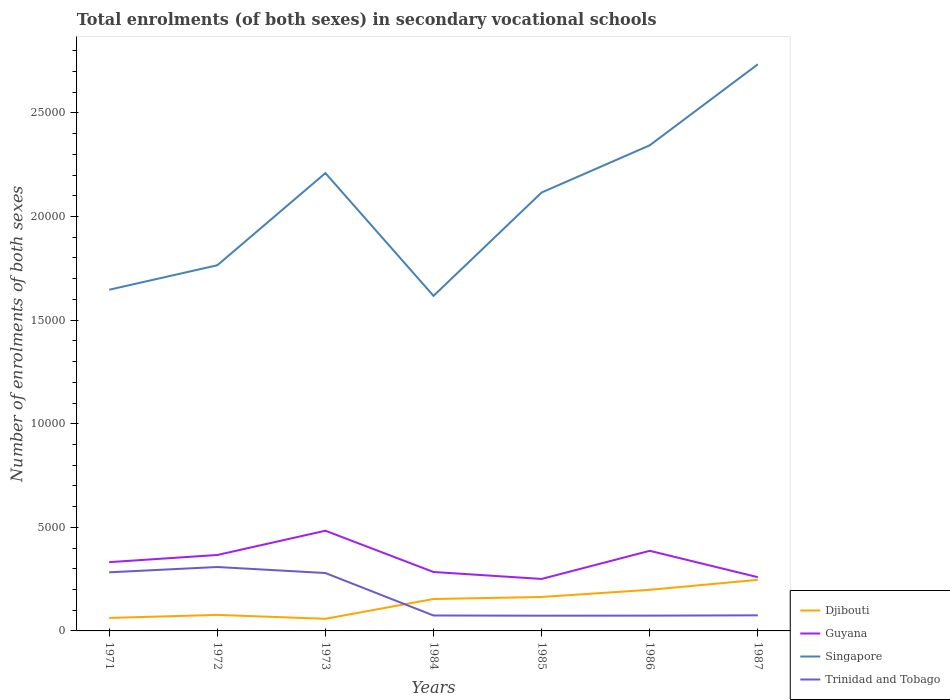Is the number of lines equal to the number of legend labels?
Offer a very short reply. Yes. Across all years, what is the maximum number of enrolments in secondary schools in Djibouti?
Provide a short and direct response. 585. In which year was the number of enrolments in secondary schools in Guyana maximum?
Your answer should be very brief. 1985. What is the total number of enrolments in secondary schools in Djibouti in the graph?
Provide a short and direct response. -444. What is the difference between the highest and the second highest number of enrolments in secondary schools in Singapore?
Ensure brevity in your answer.  1.12e+04. What is the difference between the highest and the lowest number of enrolments in secondary schools in Trinidad and Tobago?
Offer a terse response. 3. Is the number of enrolments in secondary schools in Singapore strictly greater than the number of enrolments in secondary schools in Trinidad and Tobago over the years?
Make the answer very short. No. How many lines are there?
Give a very brief answer. 4. What is the difference between two consecutive major ticks on the Y-axis?
Give a very brief answer. 5000. Does the graph contain any zero values?
Give a very brief answer. No. Does the graph contain grids?
Offer a very short reply. No. Where does the legend appear in the graph?
Ensure brevity in your answer.  Bottom right. What is the title of the graph?
Make the answer very short. Total enrolments (of both sexes) in secondary vocational schools. Does "Moldova" appear as one of the legend labels in the graph?
Provide a short and direct response. No. What is the label or title of the X-axis?
Provide a short and direct response. Years. What is the label or title of the Y-axis?
Provide a succinct answer. Number of enrolments of both sexes. What is the Number of enrolments of both sexes in Djibouti in 1971?
Provide a short and direct response. 627. What is the Number of enrolments of both sexes in Guyana in 1971?
Offer a terse response. 3319. What is the Number of enrolments of both sexes in Singapore in 1971?
Your response must be concise. 1.65e+04. What is the Number of enrolments of both sexes of Trinidad and Tobago in 1971?
Keep it short and to the point. 2829. What is the Number of enrolments of both sexes of Djibouti in 1972?
Your response must be concise. 774. What is the Number of enrolments of both sexes of Guyana in 1972?
Give a very brief answer. 3665. What is the Number of enrolments of both sexes of Singapore in 1972?
Provide a short and direct response. 1.76e+04. What is the Number of enrolments of both sexes of Trinidad and Tobago in 1972?
Your response must be concise. 3085. What is the Number of enrolments of both sexes in Djibouti in 1973?
Your answer should be very brief. 585. What is the Number of enrolments of both sexes of Guyana in 1973?
Give a very brief answer. 4836. What is the Number of enrolments of both sexes of Singapore in 1973?
Give a very brief answer. 2.21e+04. What is the Number of enrolments of both sexes in Trinidad and Tobago in 1973?
Provide a short and direct response. 2794. What is the Number of enrolments of both sexes in Djibouti in 1984?
Keep it short and to the point. 1540. What is the Number of enrolments of both sexes in Guyana in 1984?
Your response must be concise. 2844. What is the Number of enrolments of both sexes in Singapore in 1984?
Offer a terse response. 1.62e+04. What is the Number of enrolments of both sexes in Trinidad and Tobago in 1984?
Provide a short and direct response. 745. What is the Number of enrolments of both sexes in Djibouti in 1985?
Your response must be concise. 1639. What is the Number of enrolments of both sexes in Guyana in 1985?
Offer a very short reply. 2509. What is the Number of enrolments of both sexes in Singapore in 1985?
Your response must be concise. 2.12e+04. What is the Number of enrolments of both sexes in Trinidad and Tobago in 1985?
Keep it short and to the point. 735. What is the Number of enrolments of both sexes of Djibouti in 1986?
Give a very brief answer. 1984. What is the Number of enrolments of both sexes of Guyana in 1986?
Give a very brief answer. 3867. What is the Number of enrolments of both sexes of Singapore in 1986?
Offer a very short reply. 2.34e+04. What is the Number of enrolments of both sexes in Trinidad and Tobago in 1986?
Provide a short and direct response. 738. What is the Number of enrolments of both sexes in Djibouti in 1987?
Your answer should be compact. 2466. What is the Number of enrolments of both sexes of Guyana in 1987?
Your answer should be very brief. 2594. What is the Number of enrolments of both sexes of Singapore in 1987?
Offer a very short reply. 2.73e+04. What is the Number of enrolments of both sexes of Trinidad and Tobago in 1987?
Your answer should be compact. 753. Across all years, what is the maximum Number of enrolments of both sexes of Djibouti?
Provide a succinct answer. 2466. Across all years, what is the maximum Number of enrolments of both sexes of Guyana?
Offer a terse response. 4836. Across all years, what is the maximum Number of enrolments of both sexes in Singapore?
Your answer should be compact. 2.73e+04. Across all years, what is the maximum Number of enrolments of both sexes of Trinidad and Tobago?
Give a very brief answer. 3085. Across all years, what is the minimum Number of enrolments of both sexes in Djibouti?
Keep it short and to the point. 585. Across all years, what is the minimum Number of enrolments of both sexes of Guyana?
Make the answer very short. 2509. Across all years, what is the minimum Number of enrolments of both sexes in Singapore?
Your answer should be compact. 1.62e+04. Across all years, what is the minimum Number of enrolments of both sexes of Trinidad and Tobago?
Provide a succinct answer. 735. What is the total Number of enrolments of both sexes of Djibouti in the graph?
Your answer should be very brief. 9615. What is the total Number of enrolments of both sexes of Guyana in the graph?
Give a very brief answer. 2.36e+04. What is the total Number of enrolments of both sexes in Singapore in the graph?
Offer a terse response. 1.44e+05. What is the total Number of enrolments of both sexes of Trinidad and Tobago in the graph?
Your answer should be compact. 1.17e+04. What is the difference between the Number of enrolments of both sexes of Djibouti in 1971 and that in 1972?
Your answer should be very brief. -147. What is the difference between the Number of enrolments of both sexes in Guyana in 1971 and that in 1972?
Your answer should be very brief. -346. What is the difference between the Number of enrolments of both sexes of Singapore in 1971 and that in 1972?
Provide a short and direct response. -1181. What is the difference between the Number of enrolments of both sexes in Trinidad and Tobago in 1971 and that in 1972?
Make the answer very short. -256. What is the difference between the Number of enrolments of both sexes of Guyana in 1971 and that in 1973?
Offer a very short reply. -1517. What is the difference between the Number of enrolments of both sexes in Singapore in 1971 and that in 1973?
Keep it short and to the point. -5630. What is the difference between the Number of enrolments of both sexes of Djibouti in 1971 and that in 1984?
Provide a short and direct response. -913. What is the difference between the Number of enrolments of both sexes in Guyana in 1971 and that in 1984?
Provide a short and direct response. 475. What is the difference between the Number of enrolments of both sexes of Singapore in 1971 and that in 1984?
Keep it short and to the point. 296. What is the difference between the Number of enrolments of both sexes of Trinidad and Tobago in 1971 and that in 1984?
Offer a very short reply. 2084. What is the difference between the Number of enrolments of both sexes in Djibouti in 1971 and that in 1985?
Your answer should be very brief. -1012. What is the difference between the Number of enrolments of both sexes in Guyana in 1971 and that in 1985?
Make the answer very short. 810. What is the difference between the Number of enrolments of both sexes in Singapore in 1971 and that in 1985?
Your answer should be very brief. -4693. What is the difference between the Number of enrolments of both sexes of Trinidad and Tobago in 1971 and that in 1985?
Offer a very short reply. 2094. What is the difference between the Number of enrolments of both sexes of Djibouti in 1971 and that in 1986?
Ensure brevity in your answer.  -1357. What is the difference between the Number of enrolments of both sexes in Guyana in 1971 and that in 1986?
Your response must be concise. -548. What is the difference between the Number of enrolments of both sexes of Singapore in 1971 and that in 1986?
Offer a terse response. -6970. What is the difference between the Number of enrolments of both sexes in Trinidad and Tobago in 1971 and that in 1986?
Make the answer very short. 2091. What is the difference between the Number of enrolments of both sexes in Djibouti in 1971 and that in 1987?
Provide a succinct answer. -1839. What is the difference between the Number of enrolments of both sexes in Guyana in 1971 and that in 1987?
Your answer should be compact. 725. What is the difference between the Number of enrolments of both sexes of Singapore in 1971 and that in 1987?
Provide a succinct answer. -1.09e+04. What is the difference between the Number of enrolments of both sexes of Trinidad and Tobago in 1971 and that in 1987?
Make the answer very short. 2076. What is the difference between the Number of enrolments of both sexes in Djibouti in 1972 and that in 1973?
Give a very brief answer. 189. What is the difference between the Number of enrolments of both sexes of Guyana in 1972 and that in 1973?
Your response must be concise. -1171. What is the difference between the Number of enrolments of both sexes in Singapore in 1972 and that in 1973?
Keep it short and to the point. -4449. What is the difference between the Number of enrolments of both sexes in Trinidad and Tobago in 1972 and that in 1973?
Provide a succinct answer. 291. What is the difference between the Number of enrolments of both sexes in Djibouti in 1972 and that in 1984?
Provide a succinct answer. -766. What is the difference between the Number of enrolments of both sexes of Guyana in 1972 and that in 1984?
Give a very brief answer. 821. What is the difference between the Number of enrolments of both sexes in Singapore in 1972 and that in 1984?
Give a very brief answer. 1477. What is the difference between the Number of enrolments of both sexes in Trinidad and Tobago in 1972 and that in 1984?
Provide a succinct answer. 2340. What is the difference between the Number of enrolments of both sexes in Djibouti in 1972 and that in 1985?
Your response must be concise. -865. What is the difference between the Number of enrolments of both sexes of Guyana in 1972 and that in 1985?
Provide a short and direct response. 1156. What is the difference between the Number of enrolments of both sexes in Singapore in 1972 and that in 1985?
Your answer should be very brief. -3512. What is the difference between the Number of enrolments of both sexes of Trinidad and Tobago in 1972 and that in 1985?
Keep it short and to the point. 2350. What is the difference between the Number of enrolments of both sexes of Djibouti in 1972 and that in 1986?
Keep it short and to the point. -1210. What is the difference between the Number of enrolments of both sexes of Guyana in 1972 and that in 1986?
Ensure brevity in your answer.  -202. What is the difference between the Number of enrolments of both sexes in Singapore in 1972 and that in 1986?
Your answer should be compact. -5789. What is the difference between the Number of enrolments of both sexes of Trinidad and Tobago in 1972 and that in 1986?
Offer a terse response. 2347. What is the difference between the Number of enrolments of both sexes in Djibouti in 1972 and that in 1987?
Your response must be concise. -1692. What is the difference between the Number of enrolments of both sexes in Guyana in 1972 and that in 1987?
Your answer should be very brief. 1071. What is the difference between the Number of enrolments of both sexes in Singapore in 1972 and that in 1987?
Make the answer very short. -9700. What is the difference between the Number of enrolments of both sexes in Trinidad and Tobago in 1972 and that in 1987?
Provide a short and direct response. 2332. What is the difference between the Number of enrolments of both sexes in Djibouti in 1973 and that in 1984?
Offer a terse response. -955. What is the difference between the Number of enrolments of both sexes of Guyana in 1973 and that in 1984?
Make the answer very short. 1992. What is the difference between the Number of enrolments of both sexes of Singapore in 1973 and that in 1984?
Keep it short and to the point. 5926. What is the difference between the Number of enrolments of both sexes of Trinidad and Tobago in 1973 and that in 1984?
Offer a terse response. 2049. What is the difference between the Number of enrolments of both sexes of Djibouti in 1973 and that in 1985?
Make the answer very short. -1054. What is the difference between the Number of enrolments of both sexes of Guyana in 1973 and that in 1985?
Offer a very short reply. 2327. What is the difference between the Number of enrolments of both sexes of Singapore in 1973 and that in 1985?
Provide a succinct answer. 937. What is the difference between the Number of enrolments of both sexes of Trinidad and Tobago in 1973 and that in 1985?
Offer a terse response. 2059. What is the difference between the Number of enrolments of both sexes of Djibouti in 1973 and that in 1986?
Give a very brief answer. -1399. What is the difference between the Number of enrolments of both sexes in Guyana in 1973 and that in 1986?
Your answer should be very brief. 969. What is the difference between the Number of enrolments of both sexes of Singapore in 1973 and that in 1986?
Provide a short and direct response. -1340. What is the difference between the Number of enrolments of both sexes in Trinidad and Tobago in 1973 and that in 1986?
Your response must be concise. 2056. What is the difference between the Number of enrolments of both sexes in Djibouti in 1973 and that in 1987?
Ensure brevity in your answer.  -1881. What is the difference between the Number of enrolments of both sexes of Guyana in 1973 and that in 1987?
Your answer should be compact. 2242. What is the difference between the Number of enrolments of both sexes of Singapore in 1973 and that in 1987?
Give a very brief answer. -5251. What is the difference between the Number of enrolments of both sexes of Trinidad and Tobago in 1973 and that in 1987?
Offer a very short reply. 2041. What is the difference between the Number of enrolments of both sexes in Djibouti in 1984 and that in 1985?
Offer a very short reply. -99. What is the difference between the Number of enrolments of both sexes in Guyana in 1984 and that in 1985?
Offer a very short reply. 335. What is the difference between the Number of enrolments of both sexes of Singapore in 1984 and that in 1985?
Ensure brevity in your answer.  -4989. What is the difference between the Number of enrolments of both sexes of Djibouti in 1984 and that in 1986?
Provide a short and direct response. -444. What is the difference between the Number of enrolments of both sexes in Guyana in 1984 and that in 1986?
Your answer should be compact. -1023. What is the difference between the Number of enrolments of both sexes of Singapore in 1984 and that in 1986?
Give a very brief answer. -7266. What is the difference between the Number of enrolments of both sexes of Djibouti in 1984 and that in 1987?
Make the answer very short. -926. What is the difference between the Number of enrolments of both sexes of Guyana in 1984 and that in 1987?
Offer a very short reply. 250. What is the difference between the Number of enrolments of both sexes in Singapore in 1984 and that in 1987?
Your answer should be very brief. -1.12e+04. What is the difference between the Number of enrolments of both sexes in Djibouti in 1985 and that in 1986?
Keep it short and to the point. -345. What is the difference between the Number of enrolments of both sexes of Guyana in 1985 and that in 1986?
Ensure brevity in your answer.  -1358. What is the difference between the Number of enrolments of both sexes in Singapore in 1985 and that in 1986?
Keep it short and to the point. -2277. What is the difference between the Number of enrolments of both sexes in Trinidad and Tobago in 1985 and that in 1986?
Provide a short and direct response. -3. What is the difference between the Number of enrolments of both sexes in Djibouti in 1985 and that in 1987?
Make the answer very short. -827. What is the difference between the Number of enrolments of both sexes of Guyana in 1985 and that in 1987?
Offer a very short reply. -85. What is the difference between the Number of enrolments of both sexes in Singapore in 1985 and that in 1987?
Make the answer very short. -6188. What is the difference between the Number of enrolments of both sexes in Djibouti in 1986 and that in 1987?
Ensure brevity in your answer.  -482. What is the difference between the Number of enrolments of both sexes of Guyana in 1986 and that in 1987?
Offer a very short reply. 1273. What is the difference between the Number of enrolments of both sexes in Singapore in 1986 and that in 1987?
Offer a very short reply. -3911. What is the difference between the Number of enrolments of both sexes of Trinidad and Tobago in 1986 and that in 1987?
Give a very brief answer. -15. What is the difference between the Number of enrolments of both sexes in Djibouti in 1971 and the Number of enrolments of both sexes in Guyana in 1972?
Your answer should be compact. -3038. What is the difference between the Number of enrolments of both sexes in Djibouti in 1971 and the Number of enrolments of both sexes in Singapore in 1972?
Provide a succinct answer. -1.70e+04. What is the difference between the Number of enrolments of both sexes of Djibouti in 1971 and the Number of enrolments of both sexes of Trinidad and Tobago in 1972?
Your response must be concise. -2458. What is the difference between the Number of enrolments of both sexes of Guyana in 1971 and the Number of enrolments of both sexes of Singapore in 1972?
Your answer should be very brief. -1.43e+04. What is the difference between the Number of enrolments of both sexes of Guyana in 1971 and the Number of enrolments of both sexes of Trinidad and Tobago in 1972?
Provide a succinct answer. 234. What is the difference between the Number of enrolments of both sexes in Singapore in 1971 and the Number of enrolments of both sexes in Trinidad and Tobago in 1972?
Offer a terse response. 1.34e+04. What is the difference between the Number of enrolments of both sexes in Djibouti in 1971 and the Number of enrolments of both sexes in Guyana in 1973?
Provide a short and direct response. -4209. What is the difference between the Number of enrolments of both sexes of Djibouti in 1971 and the Number of enrolments of both sexes of Singapore in 1973?
Your response must be concise. -2.15e+04. What is the difference between the Number of enrolments of both sexes of Djibouti in 1971 and the Number of enrolments of both sexes of Trinidad and Tobago in 1973?
Provide a short and direct response. -2167. What is the difference between the Number of enrolments of both sexes in Guyana in 1971 and the Number of enrolments of both sexes in Singapore in 1973?
Provide a short and direct response. -1.88e+04. What is the difference between the Number of enrolments of both sexes of Guyana in 1971 and the Number of enrolments of both sexes of Trinidad and Tobago in 1973?
Your response must be concise. 525. What is the difference between the Number of enrolments of both sexes of Singapore in 1971 and the Number of enrolments of both sexes of Trinidad and Tobago in 1973?
Your response must be concise. 1.37e+04. What is the difference between the Number of enrolments of both sexes of Djibouti in 1971 and the Number of enrolments of both sexes of Guyana in 1984?
Provide a short and direct response. -2217. What is the difference between the Number of enrolments of both sexes in Djibouti in 1971 and the Number of enrolments of both sexes in Singapore in 1984?
Ensure brevity in your answer.  -1.55e+04. What is the difference between the Number of enrolments of both sexes of Djibouti in 1971 and the Number of enrolments of both sexes of Trinidad and Tobago in 1984?
Make the answer very short. -118. What is the difference between the Number of enrolments of both sexes in Guyana in 1971 and the Number of enrolments of both sexes in Singapore in 1984?
Offer a terse response. -1.29e+04. What is the difference between the Number of enrolments of both sexes in Guyana in 1971 and the Number of enrolments of both sexes in Trinidad and Tobago in 1984?
Give a very brief answer. 2574. What is the difference between the Number of enrolments of both sexes in Singapore in 1971 and the Number of enrolments of both sexes in Trinidad and Tobago in 1984?
Provide a succinct answer. 1.57e+04. What is the difference between the Number of enrolments of both sexes of Djibouti in 1971 and the Number of enrolments of both sexes of Guyana in 1985?
Your answer should be very brief. -1882. What is the difference between the Number of enrolments of both sexes in Djibouti in 1971 and the Number of enrolments of both sexes in Singapore in 1985?
Make the answer very short. -2.05e+04. What is the difference between the Number of enrolments of both sexes in Djibouti in 1971 and the Number of enrolments of both sexes in Trinidad and Tobago in 1985?
Your answer should be very brief. -108. What is the difference between the Number of enrolments of both sexes in Guyana in 1971 and the Number of enrolments of both sexes in Singapore in 1985?
Ensure brevity in your answer.  -1.78e+04. What is the difference between the Number of enrolments of both sexes of Guyana in 1971 and the Number of enrolments of both sexes of Trinidad and Tobago in 1985?
Keep it short and to the point. 2584. What is the difference between the Number of enrolments of both sexes in Singapore in 1971 and the Number of enrolments of both sexes in Trinidad and Tobago in 1985?
Make the answer very short. 1.57e+04. What is the difference between the Number of enrolments of both sexes in Djibouti in 1971 and the Number of enrolments of both sexes in Guyana in 1986?
Ensure brevity in your answer.  -3240. What is the difference between the Number of enrolments of both sexes of Djibouti in 1971 and the Number of enrolments of both sexes of Singapore in 1986?
Your answer should be compact. -2.28e+04. What is the difference between the Number of enrolments of both sexes in Djibouti in 1971 and the Number of enrolments of both sexes in Trinidad and Tobago in 1986?
Give a very brief answer. -111. What is the difference between the Number of enrolments of both sexes of Guyana in 1971 and the Number of enrolments of both sexes of Singapore in 1986?
Keep it short and to the point. -2.01e+04. What is the difference between the Number of enrolments of both sexes in Guyana in 1971 and the Number of enrolments of both sexes in Trinidad and Tobago in 1986?
Provide a succinct answer. 2581. What is the difference between the Number of enrolments of both sexes of Singapore in 1971 and the Number of enrolments of both sexes of Trinidad and Tobago in 1986?
Provide a succinct answer. 1.57e+04. What is the difference between the Number of enrolments of both sexes in Djibouti in 1971 and the Number of enrolments of both sexes in Guyana in 1987?
Provide a succinct answer. -1967. What is the difference between the Number of enrolments of both sexes of Djibouti in 1971 and the Number of enrolments of both sexes of Singapore in 1987?
Offer a terse response. -2.67e+04. What is the difference between the Number of enrolments of both sexes of Djibouti in 1971 and the Number of enrolments of both sexes of Trinidad and Tobago in 1987?
Keep it short and to the point. -126. What is the difference between the Number of enrolments of both sexes in Guyana in 1971 and the Number of enrolments of both sexes in Singapore in 1987?
Ensure brevity in your answer.  -2.40e+04. What is the difference between the Number of enrolments of both sexes in Guyana in 1971 and the Number of enrolments of both sexes in Trinidad and Tobago in 1987?
Give a very brief answer. 2566. What is the difference between the Number of enrolments of both sexes of Singapore in 1971 and the Number of enrolments of both sexes of Trinidad and Tobago in 1987?
Keep it short and to the point. 1.57e+04. What is the difference between the Number of enrolments of both sexes in Djibouti in 1972 and the Number of enrolments of both sexes in Guyana in 1973?
Offer a terse response. -4062. What is the difference between the Number of enrolments of both sexes of Djibouti in 1972 and the Number of enrolments of both sexes of Singapore in 1973?
Your response must be concise. -2.13e+04. What is the difference between the Number of enrolments of both sexes of Djibouti in 1972 and the Number of enrolments of both sexes of Trinidad and Tobago in 1973?
Your response must be concise. -2020. What is the difference between the Number of enrolments of both sexes of Guyana in 1972 and the Number of enrolments of both sexes of Singapore in 1973?
Your answer should be very brief. -1.84e+04. What is the difference between the Number of enrolments of both sexes of Guyana in 1972 and the Number of enrolments of both sexes of Trinidad and Tobago in 1973?
Give a very brief answer. 871. What is the difference between the Number of enrolments of both sexes in Singapore in 1972 and the Number of enrolments of both sexes in Trinidad and Tobago in 1973?
Provide a succinct answer. 1.49e+04. What is the difference between the Number of enrolments of both sexes of Djibouti in 1972 and the Number of enrolments of both sexes of Guyana in 1984?
Ensure brevity in your answer.  -2070. What is the difference between the Number of enrolments of both sexes in Djibouti in 1972 and the Number of enrolments of both sexes in Singapore in 1984?
Your response must be concise. -1.54e+04. What is the difference between the Number of enrolments of both sexes in Djibouti in 1972 and the Number of enrolments of both sexes in Trinidad and Tobago in 1984?
Keep it short and to the point. 29. What is the difference between the Number of enrolments of both sexes in Guyana in 1972 and the Number of enrolments of both sexes in Singapore in 1984?
Give a very brief answer. -1.25e+04. What is the difference between the Number of enrolments of both sexes in Guyana in 1972 and the Number of enrolments of both sexes in Trinidad and Tobago in 1984?
Provide a short and direct response. 2920. What is the difference between the Number of enrolments of both sexes of Singapore in 1972 and the Number of enrolments of both sexes of Trinidad and Tobago in 1984?
Give a very brief answer. 1.69e+04. What is the difference between the Number of enrolments of both sexes in Djibouti in 1972 and the Number of enrolments of both sexes in Guyana in 1985?
Keep it short and to the point. -1735. What is the difference between the Number of enrolments of both sexes of Djibouti in 1972 and the Number of enrolments of both sexes of Singapore in 1985?
Give a very brief answer. -2.04e+04. What is the difference between the Number of enrolments of both sexes of Djibouti in 1972 and the Number of enrolments of both sexes of Trinidad and Tobago in 1985?
Your response must be concise. 39. What is the difference between the Number of enrolments of both sexes of Guyana in 1972 and the Number of enrolments of both sexes of Singapore in 1985?
Ensure brevity in your answer.  -1.75e+04. What is the difference between the Number of enrolments of both sexes in Guyana in 1972 and the Number of enrolments of both sexes in Trinidad and Tobago in 1985?
Provide a short and direct response. 2930. What is the difference between the Number of enrolments of both sexes of Singapore in 1972 and the Number of enrolments of both sexes of Trinidad and Tobago in 1985?
Make the answer very short. 1.69e+04. What is the difference between the Number of enrolments of both sexes in Djibouti in 1972 and the Number of enrolments of both sexes in Guyana in 1986?
Your response must be concise. -3093. What is the difference between the Number of enrolments of both sexes of Djibouti in 1972 and the Number of enrolments of both sexes of Singapore in 1986?
Offer a terse response. -2.27e+04. What is the difference between the Number of enrolments of both sexes of Guyana in 1972 and the Number of enrolments of both sexes of Singapore in 1986?
Ensure brevity in your answer.  -1.98e+04. What is the difference between the Number of enrolments of both sexes in Guyana in 1972 and the Number of enrolments of both sexes in Trinidad and Tobago in 1986?
Provide a short and direct response. 2927. What is the difference between the Number of enrolments of both sexes of Singapore in 1972 and the Number of enrolments of both sexes of Trinidad and Tobago in 1986?
Provide a succinct answer. 1.69e+04. What is the difference between the Number of enrolments of both sexes in Djibouti in 1972 and the Number of enrolments of both sexes in Guyana in 1987?
Your answer should be compact. -1820. What is the difference between the Number of enrolments of both sexes of Djibouti in 1972 and the Number of enrolments of both sexes of Singapore in 1987?
Provide a short and direct response. -2.66e+04. What is the difference between the Number of enrolments of both sexes of Djibouti in 1972 and the Number of enrolments of both sexes of Trinidad and Tobago in 1987?
Your answer should be very brief. 21. What is the difference between the Number of enrolments of both sexes of Guyana in 1972 and the Number of enrolments of both sexes of Singapore in 1987?
Your response must be concise. -2.37e+04. What is the difference between the Number of enrolments of both sexes in Guyana in 1972 and the Number of enrolments of both sexes in Trinidad and Tobago in 1987?
Make the answer very short. 2912. What is the difference between the Number of enrolments of both sexes in Singapore in 1972 and the Number of enrolments of both sexes in Trinidad and Tobago in 1987?
Your answer should be compact. 1.69e+04. What is the difference between the Number of enrolments of both sexes in Djibouti in 1973 and the Number of enrolments of both sexes in Guyana in 1984?
Your response must be concise. -2259. What is the difference between the Number of enrolments of both sexes of Djibouti in 1973 and the Number of enrolments of both sexes of Singapore in 1984?
Provide a short and direct response. -1.56e+04. What is the difference between the Number of enrolments of both sexes of Djibouti in 1973 and the Number of enrolments of both sexes of Trinidad and Tobago in 1984?
Provide a succinct answer. -160. What is the difference between the Number of enrolments of both sexes in Guyana in 1973 and the Number of enrolments of both sexes in Singapore in 1984?
Your answer should be very brief. -1.13e+04. What is the difference between the Number of enrolments of both sexes in Guyana in 1973 and the Number of enrolments of both sexes in Trinidad and Tobago in 1984?
Your answer should be very brief. 4091. What is the difference between the Number of enrolments of both sexes of Singapore in 1973 and the Number of enrolments of both sexes of Trinidad and Tobago in 1984?
Your response must be concise. 2.14e+04. What is the difference between the Number of enrolments of both sexes in Djibouti in 1973 and the Number of enrolments of both sexes in Guyana in 1985?
Provide a succinct answer. -1924. What is the difference between the Number of enrolments of both sexes in Djibouti in 1973 and the Number of enrolments of both sexes in Singapore in 1985?
Your answer should be compact. -2.06e+04. What is the difference between the Number of enrolments of both sexes in Djibouti in 1973 and the Number of enrolments of both sexes in Trinidad and Tobago in 1985?
Provide a succinct answer. -150. What is the difference between the Number of enrolments of both sexes of Guyana in 1973 and the Number of enrolments of both sexes of Singapore in 1985?
Your answer should be very brief. -1.63e+04. What is the difference between the Number of enrolments of both sexes of Guyana in 1973 and the Number of enrolments of both sexes of Trinidad and Tobago in 1985?
Your answer should be very brief. 4101. What is the difference between the Number of enrolments of both sexes in Singapore in 1973 and the Number of enrolments of both sexes in Trinidad and Tobago in 1985?
Provide a succinct answer. 2.14e+04. What is the difference between the Number of enrolments of both sexes in Djibouti in 1973 and the Number of enrolments of both sexes in Guyana in 1986?
Your answer should be very brief. -3282. What is the difference between the Number of enrolments of both sexes of Djibouti in 1973 and the Number of enrolments of both sexes of Singapore in 1986?
Your answer should be very brief. -2.29e+04. What is the difference between the Number of enrolments of both sexes of Djibouti in 1973 and the Number of enrolments of both sexes of Trinidad and Tobago in 1986?
Offer a very short reply. -153. What is the difference between the Number of enrolments of both sexes of Guyana in 1973 and the Number of enrolments of both sexes of Singapore in 1986?
Give a very brief answer. -1.86e+04. What is the difference between the Number of enrolments of both sexes in Guyana in 1973 and the Number of enrolments of both sexes in Trinidad and Tobago in 1986?
Your answer should be compact. 4098. What is the difference between the Number of enrolments of both sexes of Singapore in 1973 and the Number of enrolments of both sexes of Trinidad and Tobago in 1986?
Offer a very short reply. 2.14e+04. What is the difference between the Number of enrolments of both sexes of Djibouti in 1973 and the Number of enrolments of both sexes of Guyana in 1987?
Your answer should be compact. -2009. What is the difference between the Number of enrolments of both sexes of Djibouti in 1973 and the Number of enrolments of both sexes of Singapore in 1987?
Make the answer very short. -2.68e+04. What is the difference between the Number of enrolments of both sexes in Djibouti in 1973 and the Number of enrolments of both sexes in Trinidad and Tobago in 1987?
Your response must be concise. -168. What is the difference between the Number of enrolments of both sexes in Guyana in 1973 and the Number of enrolments of both sexes in Singapore in 1987?
Make the answer very short. -2.25e+04. What is the difference between the Number of enrolments of both sexes of Guyana in 1973 and the Number of enrolments of both sexes of Trinidad and Tobago in 1987?
Your answer should be very brief. 4083. What is the difference between the Number of enrolments of both sexes of Singapore in 1973 and the Number of enrolments of both sexes of Trinidad and Tobago in 1987?
Keep it short and to the point. 2.13e+04. What is the difference between the Number of enrolments of both sexes of Djibouti in 1984 and the Number of enrolments of both sexes of Guyana in 1985?
Ensure brevity in your answer.  -969. What is the difference between the Number of enrolments of both sexes in Djibouti in 1984 and the Number of enrolments of both sexes in Singapore in 1985?
Your answer should be compact. -1.96e+04. What is the difference between the Number of enrolments of both sexes in Djibouti in 1984 and the Number of enrolments of both sexes in Trinidad and Tobago in 1985?
Give a very brief answer. 805. What is the difference between the Number of enrolments of both sexes in Guyana in 1984 and the Number of enrolments of both sexes in Singapore in 1985?
Provide a short and direct response. -1.83e+04. What is the difference between the Number of enrolments of both sexes of Guyana in 1984 and the Number of enrolments of both sexes of Trinidad and Tobago in 1985?
Offer a terse response. 2109. What is the difference between the Number of enrolments of both sexes in Singapore in 1984 and the Number of enrolments of both sexes in Trinidad and Tobago in 1985?
Offer a terse response. 1.54e+04. What is the difference between the Number of enrolments of both sexes of Djibouti in 1984 and the Number of enrolments of both sexes of Guyana in 1986?
Provide a succinct answer. -2327. What is the difference between the Number of enrolments of both sexes in Djibouti in 1984 and the Number of enrolments of both sexes in Singapore in 1986?
Provide a succinct answer. -2.19e+04. What is the difference between the Number of enrolments of both sexes in Djibouti in 1984 and the Number of enrolments of both sexes in Trinidad and Tobago in 1986?
Your response must be concise. 802. What is the difference between the Number of enrolments of both sexes in Guyana in 1984 and the Number of enrolments of both sexes in Singapore in 1986?
Your response must be concise. -2.06e+04. What is the difference between the Number of enrolments of both sexes of Guyana in 1984 and the Number of enrolments of both sexes of Trinidad and Tobago in 1986?
Offer a terse response. 2106. What is the difference between the Number of enrolments of both sexes of Singapore in 1984 and the Number of enrolments of both sexes of Trinidad and Tobago in 1986?
Make the answer very short. 1.54e+04. What is the difference between the Number of enrolments of both sexes of Djibouti in 1984 and the Number of enrolments of both sexes of Guyana in 1987?
Your answer should be very brief. -1054. What is the difference between the Number of enrolments of both sexes of Djibouti in 1984 and the Number of enrolments of both sexes of Singapore in 1987?
Your response must be concise. -2.58e+04. What is the difference between the Number of enrolments of both sexes of Djibouti in 1984 and the Number of enrolments of both sexes of Trinidad and Tobago in 1987?
Make the answer very short. 787. What is the difference between the Number of enrolments of both sexes in Guyana in 1984 and the Number of enrolments of both sexes in Singapore in 1987?
Give a very brief answer. -2.45e+04. What is the difference between the Number of enrolments of both sexes in Guyana in 1984 and the Number of enrolments of both sexes in Trinidad and Tobago in 1987?
Your response must be concise. 2091. What is the difference between the Number of enrolments of both sexes of Singapore in 1984 and the Number of enrolments of both sexes of Trinidad and Tobago in 1987?
Make the answer very short. 1.54e+04. What is the difference between the Number of enrolments of both sexes in Djibouti in 1985 and the Number of enrolments of both sexes in Guyana in 1986?
Make the answer very short. -2228. What is the difference between the Number of enrolments of both sexes of Djibouti in 1985 and the Number of enrolments of both sexes of Singapore in 1986?
Your answer should be compact. -2.18e+04. What is the difference between the Number of enrolments of both sexes of Djibouti in 1985 and the Number of enrolments of both sexes of Trinidad and Tobago in 1986?
Give a very brief answer. 901. What is the difference between the Number of enrolments of both sexes in Guyana in 1985 and the Number of enrolments of both sexes in Singapore in 1986?
Ensure brevity in your answer.  -2.09e+04. What is the difference between the Number of enrolments of both sexes of Guyana in 1985 and the Number of enrolments of both sexes of Trinidad and Tobago in 1986?
Your answer should be compact. 1771. What is the difference between the Number of enrolments of both sexes in Singapore in 1985 and the Number of enrolments of both sexes in Trinidad and Tobago in 1986?
Offer a terse response. 2.04e+04. What is the difference between the Number of enrolments of both sexes of Djibouti in 1985 and the Number of enrolments of both sexes of Guyana in 1987?
Make the answer very short. -955. What is the difference between the Number of enrolments of both sexes of Djibouti in 1985 and the Number of enrolments of both sexes of Singapore in 1987?
Your answer should be very brief. -2.57e+04. What is the difference between the Number of enrolments of both sexes of Djibouti in 1985 and the Number of enrolments of both sexes of Trinidad and Tobago in 1987?
Provide a succinct answer. 886. What is the difference between the Number of enrolments of both sexes of Guyana in 1985 and the Number of enrolments of both sexes of Singapore in 1987?
Your response must be concise. -2.48e+04. What is the difference between the Number of enrolments of both sexes in Guyana in 1985 and the Number of enrolments of both sexes in Trinidad and Tobago in 1987?
Make the answer very short. 1756. What is the difference between the Number of enrolments of both sexes in Singapore in 1985 and the Number of enrolments of both sexes in Trinidad and Tobago in 1987?
Give a very brief answer. 2.04e+04. What is the difference between the Number of enrolments of both sexes in Djibouti in 1986 and the Number of enrolments of both sexes in Guyana in 1987?
Keep it short and to the point. -610. What is the difference between the Number of enrolments of both sexes in Djibouti in 1986 and the Number of enrolments of both sexes in Singapore in 1987?
Ensure brevity in your answer.  -2.54e+04. What is the difference between the Number of enrolments of both sexes of Djibouti in 1986 and the Number of enrolments of both sexes of Trinidad and Tobago in 1987?
Your answer should be very brief. 1231. What is the difference between the Number of enrolments of both sexes of Guyana in 1986 and the Number of enrolments of both sexes of Singapore in 1987?
Keep it short and to the point. -2.35e+04. What is the difference between the Number of enrolments of both sexes of Guyana in 1986 and the Number of enrolments of both sexes of Trinidad and Tobago in 1987?
Provide a short and direct response. 3114. What is the difference between the Number of enrolments of both sexes of Singapore in 1986 and the Number of enrolments of both sexes of Trinidad and Tobago in 1987?
Your response must be concise. 2.27e+04. What is the average Number of enrolments of both sexes in Djibouti per year?
Ensure brevity in your answer.  1373.57. What is the average Number of enrolments of both sexes of Guyana per year?
Provide a succinct answer. 3376.29. What is the average Number of enrolments of both sexes of Singapore per year?
Offer a terse response. 2.06e+04. What is the average Number of enrolments of both sexes of Trinidad and Tobago per year?
Keep it short and to the point. 1668.43. In the year 1971, what is the difference between the Number of enrolments of both sexes in Djibouti and Number of enrolments of both sexes in Guyana?
Make the answer very short. -2692. In the year 1971, what is the difference between the Number of enrolments of both sexes in Djibouti and Number of enrolments of both sexes in Singapore?
Make the answer very short. -1.58e+04. In the year 1971, what is the difference between the Number of enrolments of both sexes in Djibouti and Number of enrolments of both sexes in Trinidad and Tobago?
Offer a very short reply. -2202. In the year 1971, what is the difference between the Number of enrolments of both sexes in Guyana and Number of enrolments of both sexes in Singapore?
Provide a succinct answer. -1.31e+04. In the year 1971, what is the difference between the Number of enrolments of both sexes of Guyana and Number of enrolments of both sexes of Trinidad and Tobago?
Give a very brief answer. 490. In the year 1971, what is the difference between the Number of enrolments of both sexes of Singapore and Number of enrolments of both sexes of Trinidad and Tobago?
Make the answer very short. 1.36e+04. In the year 1972, what is the difference between the Number of enrolments of both sexes of Djibouti and Number of enrolments of both sexes of Guyana?
Offer a terse response. -2891. In the year 1972, what is the difference between the Number of enrolments of both sexes in Djibouti and Number of enrolments of both sexes in Singapore?
Provide a succinct answer. -1.69e+04. In the year 1972, what is the difference between the Number of enrolments of both sexes of Djibouti and Number of enrolments of both sexes of Trinidad and Tobago?
Your response must be concise. -2311. In the year 1972, what is the difference between the Number of enrolments of both sexes of Guyana and Number of enrolments of both sexes of Singapore?
Your answer should be very brief. -1.40e+04. In the year 1972, what is the difference between the Number of enrolments of both sexes of Guyana and Number of enrolments of both sexes of Trinidad and Tobago?
Give a very brief answer. 580. In the year 1972, what is the difference between the Number of enrolments of both sexes of Singapore and Number of enrolments of both sexes of Trinidad and Tobago?
Your answer should be very brief. 1.46e+04. In the year 1973, what is the difference between the Number of enrolments of both sexes in Djibouti and Number of enrolments of both sexes in Guyana?
Provide a succinct answer. -4251. In the year 1973, what is the difference between the Number of enrolments of both sexes in Djibouti and Number of enrolments of both sexes in Singapore?
Give a very brief answer. -2.15e+04. In the year 1973, what is the difference between the Number of enrolments of both sexes of Djibouti and Number of enrolments of both sexes of Trinidad and Tobago?
Your answer should be compact. -2209. In the year 1973, what is the difference between the Number of enrolments of both sexes of Guyana and Number of enrolments of both sexes of Singapore?
Your response must be concise. -1.73e+04. In the year 1973, what is the difference between the Number of enrolments of both sexes in Guyana and Number of enrolments of both sexes in Trinidad and Tobago?
Give a very brief answer. 2042. In the year 1973, what is the difference between the Number of enrolments of both sexes of Singapore and Number of enrolments of both sexes of Trinidad and Tobago?
Keep it short and to the point. 1.93e+04. In the year 1984, what is the difference between the Number of enrolments of both sexes in Djibouti and Number of enrolments of both sexes in Guyana?
Provide a succinct answer. -1304. In the year 1984, what is the difference between the Number of enrolments of both sexes in Djibouti and Number of enrolments of both sexes in Singapore?
Your response must be concise. -1.46e+04. In the year 1984, what is the difference between the Number of enrolments of both sexes of Djibouti and Number of enrolments of both sexes of Trinidad and Tobago?
Give a very brief answer. 795. In the year 1984, what is the difference between the Number of enrolments of both sexes in Guyana and Number of enrolments of both sexes in Singapore?
Offer a very short reply. -1.33e+04. In the year 1984, what is the difference between the Number of enrolments of both sexes in Guyana and Number of enrolments of both sexes in Trinidad and Tobago?
Offer a very short reply. 2099. In the year 1984, what is the difference between the Number of enrolments of both sexes of Singapore and Number of enrolments of both sexes of Trinidad and Tobago?
Your answer should be compact. 1.54e+04. In the year 1985, what is the difference between the Number of enrolments of both sexes of Djibouti and Number of enrolments of both sexes of Guyana?
Keep it short and to the point. -870. In the year 1985, what is the difference between the Number of enrolments of both sexes of Djibouti and Number of enrolments of both sexes of Singapore?
Make the answer very short. -1.95e+04. In the year 1985, what is the difference between the Number of enrolments of both sexes of Djibouti and Number of enrolments of both sexes of Trinidad and Tobago?
Provide a short and direct response. 904. In the year 1985, what is the difference between the Number of enrolments of both sexes of Guyana and Number of enrolments of both sexes of Singapore?
Ensure brevity in your answer.  -1.87e+04. In the year 1985, what is the difference between the Number of enrolments of both sexes in Guyana and Number of enrolments of both sexes in Trinidad and Tobago?
Your answer should be compact. 1774. In the year 1985, what is the difference between the Number of enrolments of both sexes in Singapore and Number of enrolments of both sexes in Trinidad and Tobago?
Provide a succinct answer. 2.04e+04. In the year 1986, what is the difference between the Number of enrolments of both sexes in Djibouti and Number of enrolments of both sexes in Guyana?
Your response must be concise. -1883. In the year 1986, what is the difference between the Number of enrolments of both sexes in Djibouti and Number of enrolments of both sexes in Singapore?
Keep it short and to the point. -2.15e+04. In the year 1986, what is the difference between the Number of enrolments of both sexes in Djibouti and Number of enrolments of both sexes in Trinidad and Tobago?
Make the answer very short. 1246. In the year 1986, what is the difference between the Number of enrolments of both sexes in Guyana and Number of enrolments of both sexes in Singapore?
Make the answer very short. -1.96e+04. In the year 1986, what is the difference between the Number of enrolments of both sexes of Guyana and Number of enrolments of both sexes of Trinidad and Tobago?
Offer a very short reply. 3129. In the year 1986, what is the difference between the Number of enrolments of both sexes in Singapore and Number of enrolments of both sexes in Trinidad and Tobago?
Give a very brief answer. 2.27e+04. In the year 1987, what is the difference between the Number of enrolments of both sexes in Djibouti and Number of enrolments of both sexes in Guyana?
Give a very brief answer. -128. In the year 1987, what is the difference between the Number of enrolments of both sexes of Djibouti and Number of enrolments of both sexes of Singapore?
Provide a short and direct response. -2.49e+04. In the year 1987, what is the difference between the Number of enrolments of both sexes in Djibouti and Number of enrolments of both sexes in Trinidad and Tobago?
Provide a short and direct response. 1713. In the year 1987, what is the difference between the Number of enrolments of both sexes of Guyana and Number of enrolments of both sexes of Singapore?
Keep it short and to the point. -2.48e+04. In the year 1987, what is the difference between the Number of enrolments of both sexes of Guyana and Number of enrolments of both sexes of Trinidad and Tobago?
Provide a short and direct response. 1841. In the year 1987, what is the difference between the Number of enrolments of both sexes of Singapore and Number of enrolments of both sexes of Trinidad and Tobago?
Your response must be concise. 2.66e+04. What is the ratio of the Number of enrolments of both sexes of Djibouti in 1971 to that in 1972?
Offer a terse response. 0.81. What is the ratio of the Number of enrolments of both sexes of Guyana in 1971 to that in 1972?
Offer a very short reply. 0.91. What is the ratio of the Number of enrolments of both sexes of Singapore in 1971 to that in 1972?
Ensure brevity in your answer.  0.93. What is the ratio of the Number of enrolments of both sexes in Trinidad and Tobago in 1971 to that in 1972?
Your answer should be very brief. 0.92. What is the ratio of the Number of enrolments of both sexes in Djibouti in 1971 to that in 1973?
Offer a very short reply. 1.07. What is the ratio of the Number of enrolments of both sexes of Guyana in 1971 to that in 1973?
Provide a succinct answer. 0.69. What is the ratio of the Number of enrolments of both sexes in Singapore in 1971 to that in 1973?
Ensure brevity in your answer.  0.75. What is the ratio of the Number of enrolments of both sexes of Trinidad and Tobago in 1971 to that in 1973?
Provide a short and direct response. 1.01. What is the ratio of the Number of enrolments of both sexes in Djibouti in 1971 to that in 1984?
Offer a very short reply. 0.41. What is the ratio of the Number of enrolments of both sexes in Guyana in 1971 to that in 1984?
Your answer should be compact. 1.17. What is the ratio of the Number of enrolments of both sexes in Singapore in 1971 to that in 1984?
Provide a short and direct response. 1.02. What is the ratio of the Number of enrolments of both sexes of Trinidad and Tobago in 1971 to that in 1984?
Your response must be concise. 3.8. What is the ratio of the Number of enrolments of both sexes in Djibouti in 1971 to that in 1985?
Provide a short and direct response. 0.38. What is the ratio of the Number of enrolments of both sexes of Guyana in 1971 to that in 1985?
Make the answer very short. 1.32. What is the ratio of the Number of enrolments of both sexes of Singapore in 1971 to that in 1985?
Provide a short and direct response. 0.78. What is the ratio of the Number of enrolments of both sexes in Trinidad and Tobago in 1971 to that in 1985?
Your answer should be very brief. 3.85. What is the ratio of the Number of enrolments of both sexes of Djibouti in 1971 to that in 1986?
Your answer should be compact. 0.32. What is the ratio of the Number of enrolments of both sexes of Guyana in 1971 to that in 1986?
Give a very brief answer. 0.86. What is the ratio of the Number of enrolments of both sexes in Singapore in 1971 to that in 1986?
Your response must be concise. 0.7. What is the ratio of the Number of enrolments of both sexes in Trinidad and Tobago in 1971 to that in 1986?
Keep it short and to the point. 3.83. What is the ratio of the Number of enrolments of both sexes in Djibouti in 1971 to that in 1987?
Offer a terse response. 0.25. What is the ratio of the Number of enrolments of both sexes of Guyana in 1971 to that in 1987?
Your response must be concise. 1.28. What is the ratio of the Number of enrolments of both sexes of Singapore in 1971 to that in 1987?
Keep it short and to the point. 0.6. What is the ratio of the Number of enrolments of both sexes in Trinidad and Tobago in 1971 to that in 1987?
Provide a short and direct response. 3.76. What is the ratio of the Number of enrolments of both sexes of Djibouti in 1972 to that in 1973?
Give a very brief answer. 1.32. What is the ratio of the Number of enrolments of both sexes in Guyana in 1972 to that in 1973?
Offer a very short reply. 0.76. What is the ratio of the Number of enrolments of both sexes in Singapore in 1972 to that in 1973?
Keep it short and to the point. 0.8. What is the ratio of the Number of enrolments of both sexes of Trinidad and Tobago in 1972 to that in 1973?
Provide a short and direct response. 1.1. What is the ratio of the Number of enrolments of both sexes of Djibouti in 1972 to that in 1984?
Give a very brief answer. 0.5. What is the ratio of the Number of enrolments of both sexes in Guyana in 1972 to that in 1984?
Provide a succinct answer. 1.29. What is the ratio of the Number of enrolments of both sexes in Singapore in 1972 to that in 1984?
Offer a very short reply. 1.09. What is the ratio of the Number of enrolments of both sexes in Trinidad and Tobago in 1972 to that in 1984?
Your answer should be very brief. 4.14. What is the ratio of the Number of enrolments of both sexes in Djibouti in 1972 to that in 1985?
Ensure brevity in your answer.  0.47. What is the ratio of the Number of enrolments of both sexes of Guyana in 1972 to that in 1985?
Your answer should be very brief. 1.46. What is the ratio of the Number of enrolments of both sexes of Singapore in 1972 to that in 1985?
Offer a terse response. 0.83. What is the ratio of the Number of enrolments of both sexes of Trinidad and Tobago in 1972 to that in 1985?
Your answer should be very brief. 4.2. What is the ratio of the Number of enrolments of both sexes of Djibouti in 1972 to that in 1986?
Give a very brief answer. 0.39. What is the ratio of the Number of enrolments of both sexes of Guyana in 1972 to that in 1986?
Offer a very short reply. 0.95. What is the ratio of the Number of enrolments of both sexes in Singapore in 1972 to that in 1986?
Make the answer very short. 0.75. What is the ratio of the Number of enrolments of both sexes in Trinidad and Tobago in 1972 to that in 1986?
Provide a succinct answer. 4.18. What is the ratio of the Number of enrolments of both sexes of Djibouti in 1972 to that in 1987?
Provide a short and direct response. 0.31. What is the ratio of the Number of enrolments of both sexes of Guyana in 1972 to that in 1987?
Offer a very short reply. 1.41. What is the ratio of the Number of enrolments of both sexes in Singapore in 1972 to that in 1987?
Offer a very short reply. 0.65. What is the ratio of the Number of enrolments of both sexes in Trinidad and Tobago in 1972 to that in 1987?
Your response must be concise. 4.1. What is the ratio of the Number of enrolments of both sexes of Djibouti in 1973 to that in 1984?
Offer a terse response. 0.38. What is the ratio of the Number of enrolments of both sexes of Guyana in 1973 to that in 1984?
Offer a terse response. 1.7. What is the ratio of the Number of enrolments of both sexes of Singapore in 1973 to that in 1984?
Your answer should be compact. 1.37. What is the ratio of the Number of enrolments of both sexes in Trinidad and Tobago in 1973 to that in 1984?
Provide a short and direct response. 3.75. What is the ratio of the Number of enrolments of both sexes of Djibouti in 1973 to that in 1985?
Your response must be concise. 0.36. What is the ratio of the Number of enrolments of both sexes of Guyana in 1973 to that in 1985?
Give a very brief answer. 1.93. What is the ratio of the Number of enrolments of both sexes of Singapore in 1973 to that in 1985?
Give a very brief answer. 1.04. What is the ratio of the Number of enrolments of both sexes of Trinidad and Tobago in 1973 to that in 1985?
Ensure brevity in your answer.  3.8. What is the ratio of the Number of enrolments of both sexes of Djibouti in 1973 to that in 1986?
Your answer should be very brief. 0.29. What is the ratio of the Number of enrolments of both sexes of Guyana in 1973 to that in 1986?
Ensure brevity in your answer.  1.25. What is the ratio of the Number of enrolments of both sexes in Singapore in 1973 to that in 1986?
Ensure brevity in your answer.  0.94. What is the ratio of the Number of enrolments of both sexes in Trinidad and Tobago in 1973 to that in 1986?
Ensure brevity in your answer.  3.79. What is the ratio of the Number of enrolments of both sexes of Djibouti in 1973 to that in 1987?
Provide a succinct answer. 0.24. What is the ratio of the Number of enrolments of both sexes of Guyana in 1973 to that in 1987?
Provide a succinct answer. 1.86. What is the ratio of the Number of enrolments of both sexes of Singapore in 1973 to that in 1987?
Ensure brevity in your answer.  0.81. What is the ratio of the Number of enrolments of both sexes of Trinidad and Tobago in 1973 to that in 1987?
Give a very brief answer. 3.71. What is the ratio of the Number of enrolments of both sexes of Djibouti in 1984 to that in 1985?
Provide a succinct answer. 0.94. What is the ratio of the Number of enrolments of both sexes in Guyana in 1984 to that in 1985?
Your answer should be very brief. 1.13. What is the ratio of the Number of enrolments of both sexes of Singapore in 1984 to that in 1985?
Provide a short and direct response. 0.76. What is the ratio of the Number of enrolments of both sexes of Trinidad and Tobago in 1984 to that in 1985?
Offer a very short reply. 1.01. What is the ratio of the Number of enrolments of both sexes of Djibouti in 1984 to that in 1986?
Make the answer very short. 0.78. What is the ratio of the Number of enrolments of both sexes of Guyana in 1984 to that in 1986?
Your answer should be compact. 0.74. What is the ratio of the Number of enrolments of both sexes of Singapore in 1984 to that in 1986?
Your response must be concise. 0.69. What is the ratio of the Number of enrolments of both sexes in Trinidad and Tobago in 1984 to that in 1986?
Provide a succinct answer. 1.01. What is the ratio of the Number of enrolments of both sexes in Djibouti in 1984 to that in 1987?
Offer a very short reply. 0.62. What is the ratio of the Number of enrolments of both sexes of Guyana in 1984 to that in 1987?
Your response must be concise. 1.1. What is the ratio of the Number of enrolments of both sexes in Singapore in 1984 to that in 1987?
Keep it short and to the point. 0.59. What is the ratio of the Number of enrolments of both sexes of Trinidad and Tobago in 1984 to that in 1987?
Provide a short and direct response. 0.99. What is the ratio of the Number of enrolments of both sexes in Djibouti in 1985 to that in 1986?
Give a very brief answer. 0.83. What is the ratio of the Number of enrolments of both sexes in Guyana in 1985 to that in 1986?
Offer a very short reply. 0.65. What is the ratio of the Number of enrolments of both sexes of Singapore in 1985 to that in 1986?
Offer a very short reply. 0.9. What is the ratio of the Number of enrolments of both sexes of Trinidad and Tobago in 1985 to that in 1986?
Ensure brevity in your answer.  1. What is the ratio of the Number of enrolments of both sexes of Djibouti in 1985 to that in 1987?
Provide a short and direct response. 0.66. What is the ratio of the Number of enrolments of both sexes in Guyana in 1985 to that in 1987?
Offer a terse response. 0.97. What is the ratio of the Number of enrolments of both sexes in Singapore in 1985 to that in 1987?
Offer a very short reply. 0.77. What is the ratio of the Number of enrolments of both sexes of Trinidad and Tobago in 1985 to that in 1987?
Keep it short and to the point. 0.98. What is the ratio of the Number of enrolments of both sexes in Djibouti in 1986 to that in 1987?
Provide a short and direct response. 0.8. What is the ratio of the Number of enrolments of both sexes of Guyana in 1986 to that in 1987?
Make the answer very short. 1.49. What is the ratio of the Number of enrolments of both sexes in Singapore in 1986 to that in 1987?
Give a very brief answer. 0.86. What is the ratio of the Number of enrolments of both sexes in Trinidad and Tobago in 1986 to that in 1987?
Provide a short and direct response. 0.98. What is the difference between the highest and the second highest Number of enrolments of both sexes of Djibouti?
Keep it short and to the point. 482. What is the difference between the highest and the second highest Number of enrolments of both sexes of Guyana?
Give a very brief answer. 969. What is the difference between the highest and the second highest Number of enrolments of both sexes of Singapore?
Your answer should be compact. 3911. What is the difference between the highest and the second highest Number of enrolments of both sexes in Trinidad and Tobago?
Make the answer very short. 256. What is the difference between the highest and the lowest Number of enrolments of both sexes in Djibouti?
Your answer should be compact. 1881. What is the difference between the highest and the lowest Number of enrolments of both sexes in Guyana?
Give a very brief answer. 2327. What is the difference between the highest and the lowest Number of enrolments of both sexes of Singapore?
Your answer should be compact. 1.12e+04. What is the difference between the highest and the lowest Number of enrolments of both sexes in Trinidad and Tobago?
Give a very brief answer. 2350. 